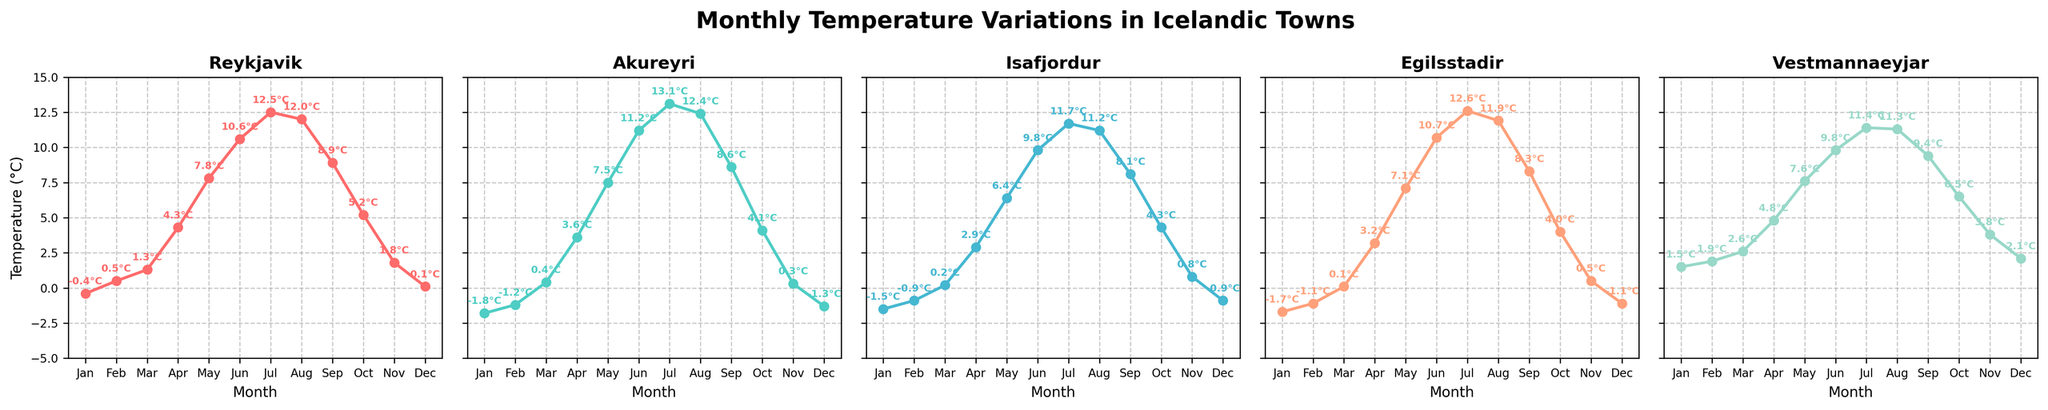What is the highest temperature recorded in Reykjavik throughout the year? First, locate Reykjavik's subplot. Identify the maximum temperature annotated on the plot throughout all months.
Answer: 12.5°C Which town has the highest temperature in July? Find July on all subplots and compare the temperatures. Akureyri has the highest temperature at 13.1°C in July.
Answer: Akureyri In which month does Isafjordur experience its lowest temperature? Look at Isafjordur's subplot and find the lowest temperature point. The lowest temperature in Isafjordur is -1.5°C in January.
Answer: January How does the August temperature in Egilsstadir compare to the January temperature in Akureyri? Locate the temperatures for August in Egilsstadir and January in Akureyri. Compare 11.9°C in Egilsstadir with -1.8°C in Akureyri. Egilsstadir in August is significantly warmer.
Answer: Egilsstadir is much warmer in August What's the average temperature in Vestmannaeyjar between May and September? Add the temperatures for May, June, July, August, and September in the Vestmannaeyjar subplot: 7.6 + 9.8 + 11.4 + 11.3 + 9.4. Divide by 5 to find the average.
Answer: 9.9°C Which month shows the biggest temperature difference between Reykjavik and Akureyri? Compare monthly temperatures for Reykjavik and Akureyri and find the month with the maximum difference. January shows the biggest difference with Reykjavik at -0.4°C and Akureyri at -1.8°C.
Answer: January Is the temperature trend in Egilsstadir generally increasing or decreasing from January to December? Observe the overall direction of the temperature plot in Egilsstadir from start (January) to end (December). The temperature trend generally increases.
Answer: Increasing Which town has the mildest winter, based on the temperatures from January to March? Compare the temperatures from January to March for all towns, identifying the town with the highest average. Vestmannaeyjar has the mildest winter with temperatures 1.5°C, 1.9°C, and 2.6°C.
Answer: Vestmannaeyjar How does Reykjavik's average temperature in the summer months (June to August) compare with Isafjordur's average for the same period? Calculate the average temperature for June, July, and August in both Reykjavik and Isafjordur. Reykjavik averages (10.6 + 12.5 + 12.0)/3 = 11.7°C; Isafjordur averages (9.8 + 11.7 + 11.2)/3 = 10.9°C.
Answer: Reykjavik has a higher average summer temperature 